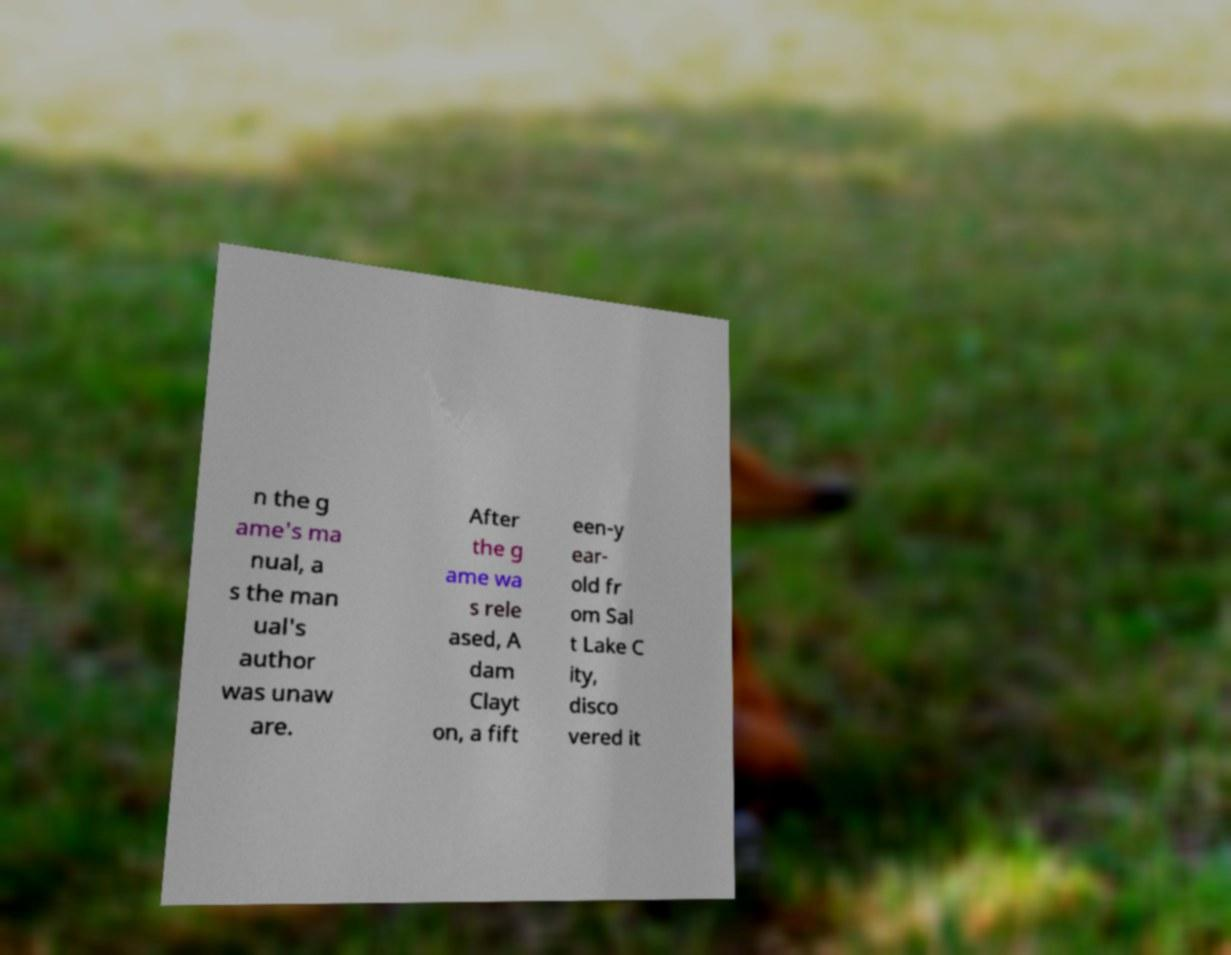Can you read and provide the text displayed in the image?This photo seems to have some interesting text. Can you extract and type it out for me? n the g ame's ma nual, a s the man ual's author was unaw are. After the g ame wa s rele ased, A dam Clayt on, a fift een-y ear- old fr om Sal t Lake C ity, disco vered it 